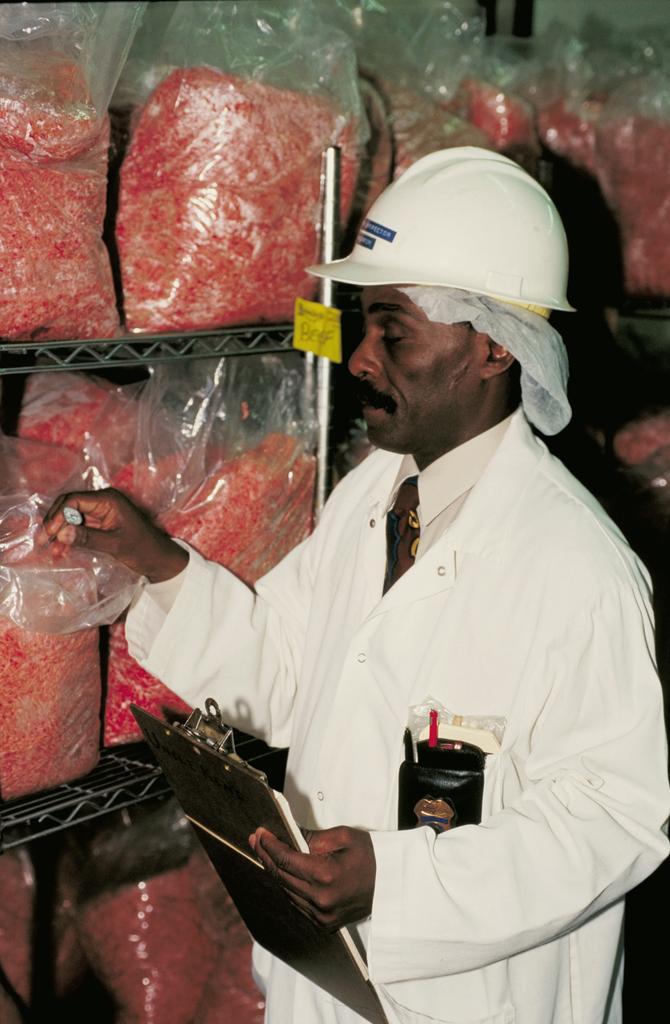In one or two sentences, can you explain what this image depicts? In the image in the center, we can see one person standing and he is holding plank and he is wearing a hat, which is in white color. In front of him, we can see racks, onenote and plastic cover. In the plastic covers, we can see some food products. 